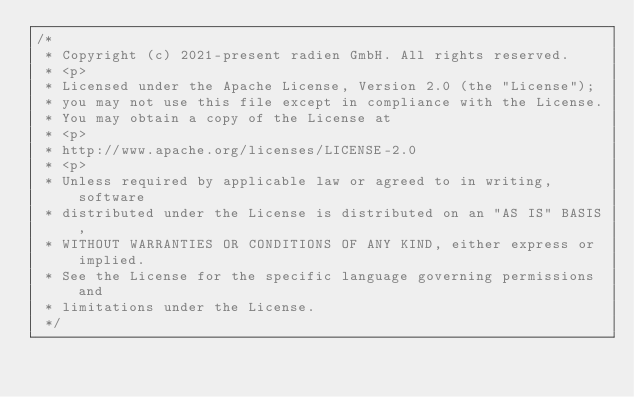<code> <loc_0><loc_0><loc_500><loc_500><_Java_>/*
 * Copyright (c) 2021-present radien GmbH. All rights reserved.
 * <p>
 * Licensed under the Apache License, Version 2.0 (the "License");
 * you may not use this file except in compliance with the License.
 * You may obtain a copy of the License at
 * <p>
 * http://www.apache.org/licenses/LICENSE-2.0
 * <p>
 * Unless required by applicable law or agreed to in writing, software
 * distributed under the License is distributed on an "AS IS" BASIS,
 * WITHOUT WARRANTIES OR CONDITIONS OF ANY KIND, either express or implied.
 * See the License for the specific language governing permissions and
 * limitations under the License.
 */</code> 